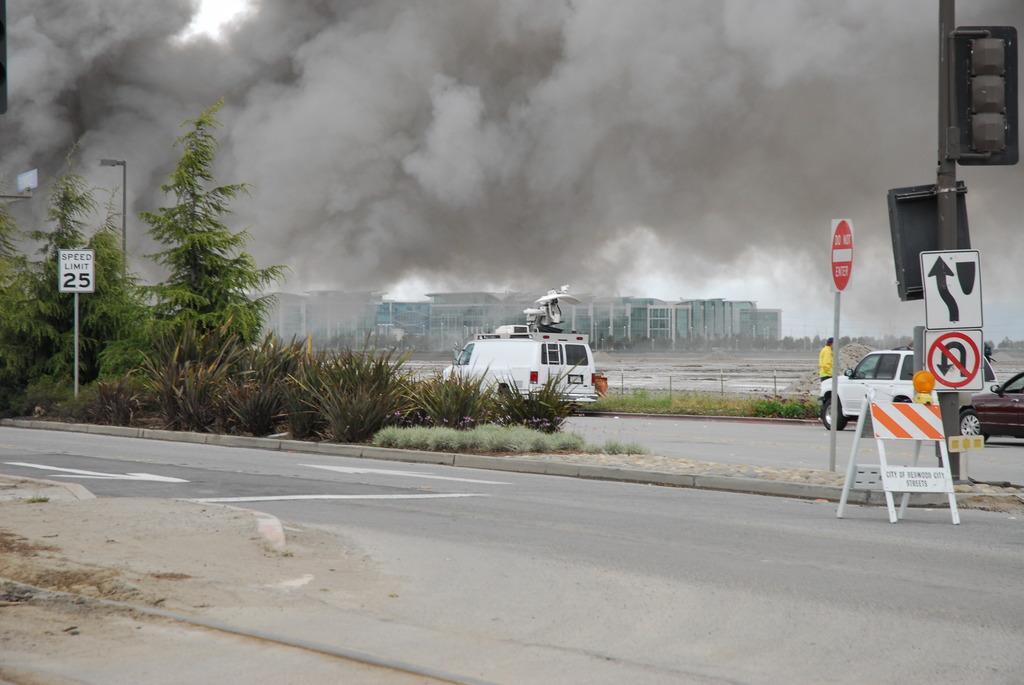How would you summarize this image in a sentence or two? In this image we can see vehicles on the road, beside that we can see one person standing, on the right we can see sign boards, text written on the board and signal pole. And on the right we can see the trees, plants, grass. And we can see the buildings, beside that we can see fumes, at the top we can see the sky. 